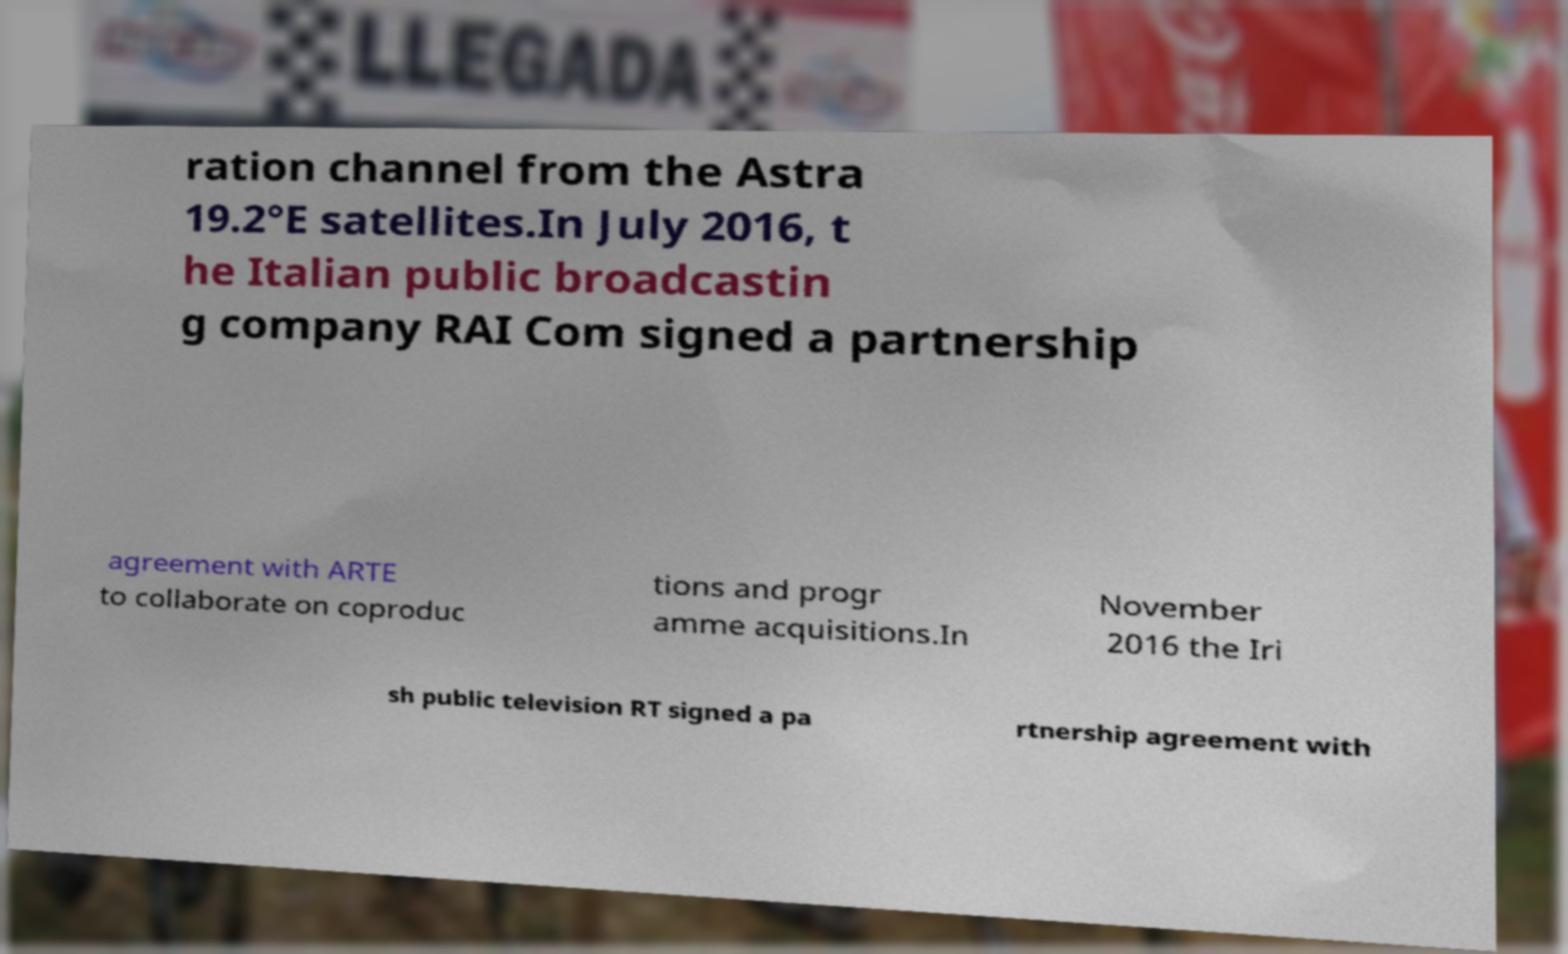Can you read and provide the text displayed in the image?This photo seems to have some interesting text. Can you extract and type it out for me? ration channel from the Astra 19.2°E satellites.In July 2016, t he Italian public broadcastin g company RAI Com signed a partnership agreement with ARTE to collaborate on coproduc tions and progr amme acquisitions.In November 2016 the Iri sh public television RT signed a pa rtnership agreement with 